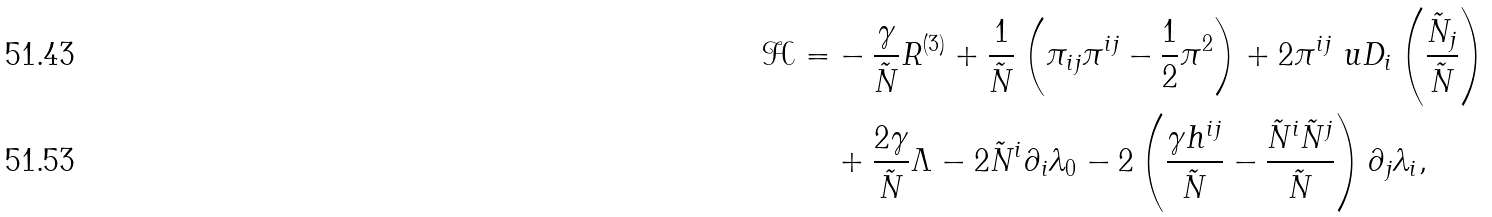Convert formula to latex. <formula><loc_0><loc_0><loc_500><loc_500>\mathcal { H } = & - \frac { \gamma } { \tilde { N } } R ^ { ( 3 ) } + \frac { 1 } { \tilde { N } } \left ( \pi _ { i j } \pi ^ { i j } - \frac { 1 } { 2 } \pi ^ { 2 } \right ) + 2 \pi ^ { i j } \ u D _ { i } \left ( \frac { \tilde { N } _ { j } } { \tilde { N } } \right ) \\ & + \frac { 2 \gamma } { \tilde { N } } \Lambda - 2 \tilde { N } ^ { i } \partial _ { i } \lambda _ { 0 } - 2 \left ( \frac { \gamma h ^ { i j } } { \tilde { N } } - \frac { \tilde { N } ^ { i } \tilde { N } ^ { j } } { \tilde { N } } \right ) \partial _ { j } \lambda _ { i } ,</formula> 